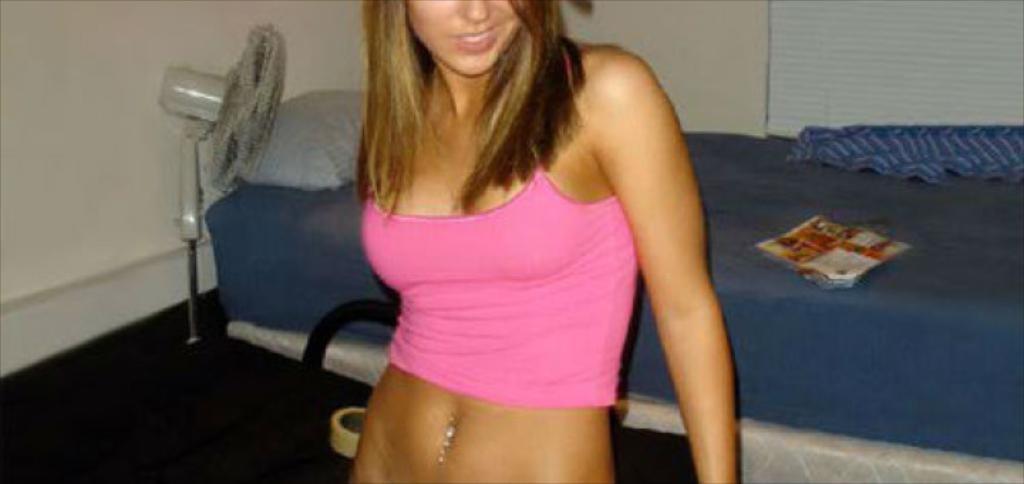Describe this image in one or two sentences. In the picture there is a woman standing in front of a bed,she is wearing pink top and behind the woman there is a table fan. 